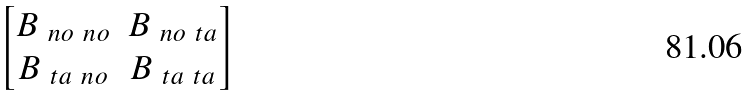<formula> <loc_0><loc_0><loc_500><loc_500>\begin{bmatrix} B _ { \ n o \ n o } & B _ { \ n o \ t a } \\ B _ { \ t a \ n o } & B _ { \ t a \ t a } \end{bmatrix}</formula> 